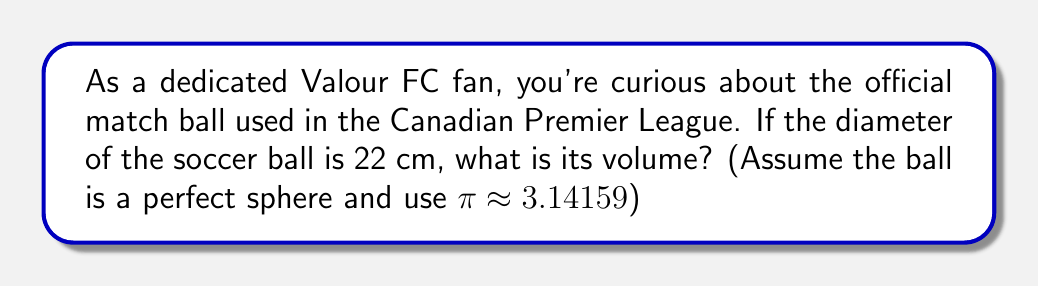Teach me how to tackle this problem. To find the volume of a soccer ball, we need to use the formula for the volume of a sphere:

$$V = \frac{4}{3}\pi r^3$$

Where:
$V$ is the volume
$r$ is the radius of the sphere

We are given the diameter of the ball, which is 22 cm. To find the radius, we need to divide the diameter by 2:

$$r = \frac{22}{2} = 11 \text{ cm}$$

Now we can substitute this into our volume formula:

$$\begin{align}
V &= \frac{4}{3}\pi (11)^3 \\[6pt]
&= \frac{4}{3} \cdot 3.14159 \cdot 1331 \\[6pt]
&= 4 \cdot 1.04719667 \cdot 1331 \\[6pt]
&= 5575.28 \text{ cm}^3
\end{align}$$

Rounding to the nearest whole number:

$$V \approx 5575 \text{ cm}^3$$

[asy]
import geometry;

size(100);
draw(circle((0,0),1), rgb(0.7,0,0));
draw((0,0)--(1,0), arrow=Arrow(TeXHead));
label("$r$", (0.5,0.1), N);
draw((-1.2,0)--(1.2,0), dashed);
label("$d$", (0,-0.1), S);
[/asy]
Answer: The volume of the soccer ball is approximately 5575 cm³. 